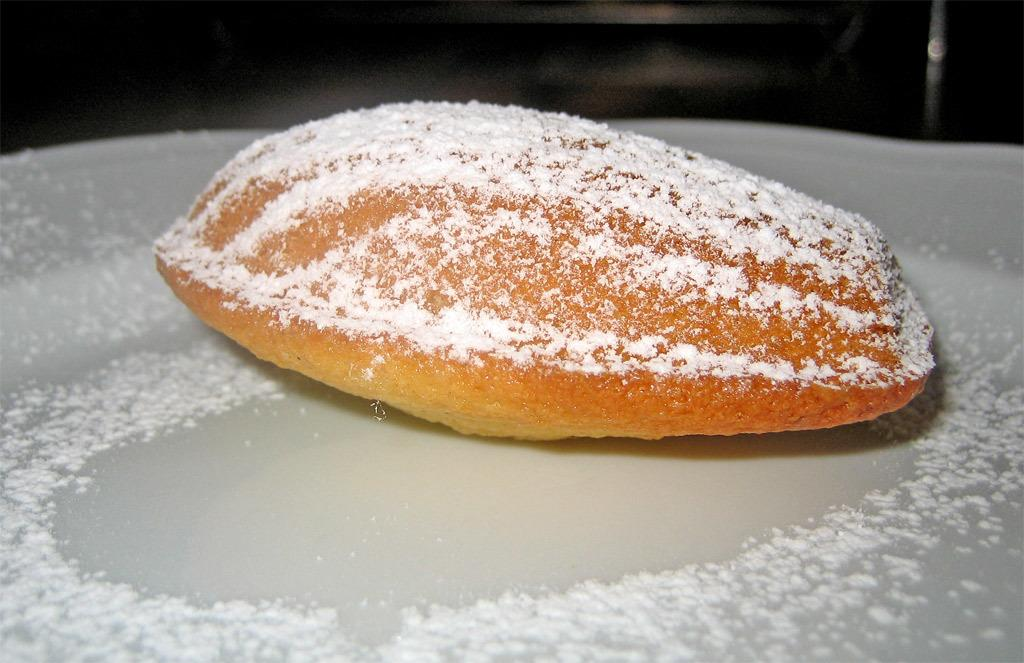What is the main subject of the image? The main subject of the image is food. What can be observed about the surface on which the food is placed? The food is on a white surface. What colors are visible in the food? The food has brown and white colors. How does the fog affect the food in the image? There is no fog present in the image, so it cannot affect the food. 